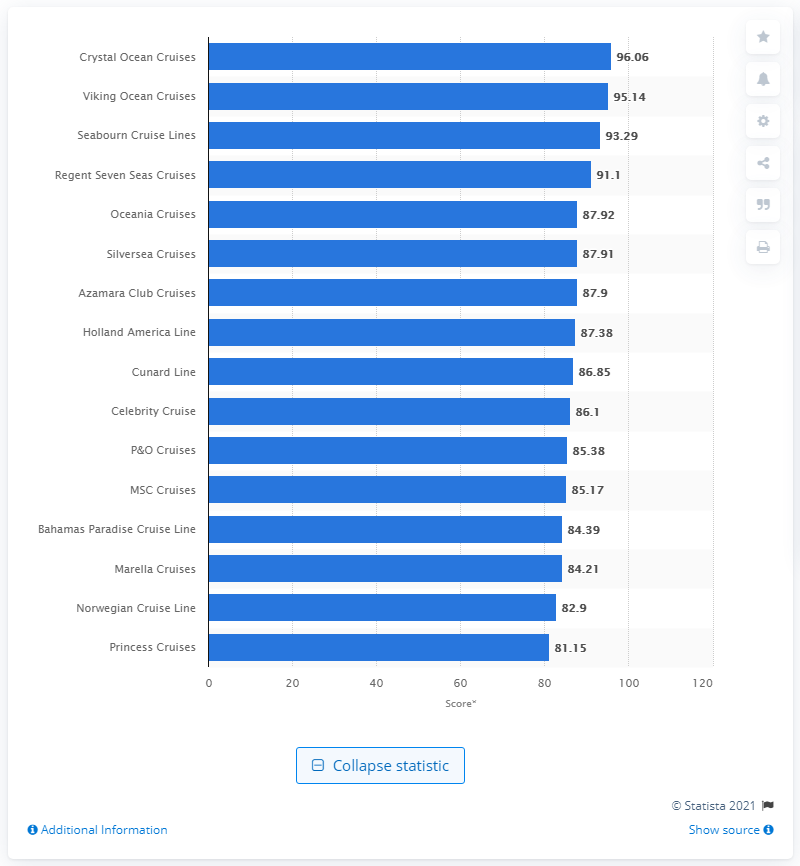Give some essential details in this illustration. According to the readers of Condé Nast Traveler, Crystal Ocean Cruises was named the best midsize-ship cruise line. Crystal Ocean Cruises received a score of 96.06 out of 100, indicating high levels of customer satisfaction and performance excellence. 